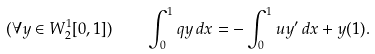Convert formula to latex. <formula><loc_0><loc_0><loc_500><loc_500>( \forall y \in W _ { 2 } ^ { 1 } [ 0 , 1 ] ) \quad \int _ { 0 } ^ { 1 } q y \, d x = - \int _ { 0 } ^ { 1 } u y ^ { \prime } \, d x + y ( 1 ) .</formula> 